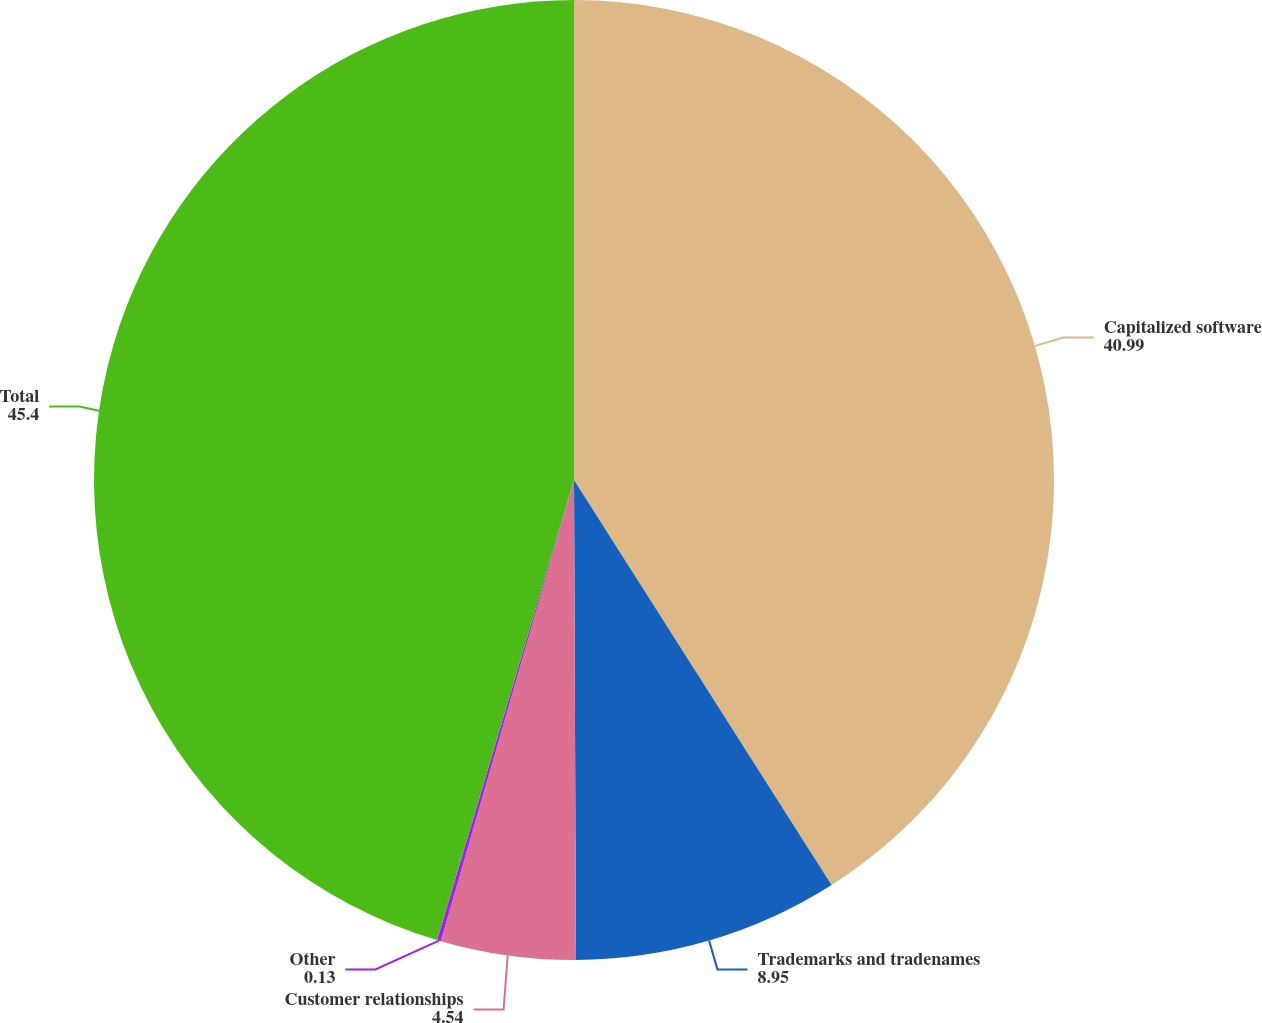Convert chart to OTSL. <chart><loc_0><loc_0><loc_500><loc_500><pie_chart><fcel>Capitalized software<fcel>Trademarks and tradenames<fcel>Customer relationships<fcel>Other<fcel>Total<nl><fcel>40.99%<fcel>8.95%<fcel>4.54%<fcel>0.13%<fcel>45.4%<nl></chart> 